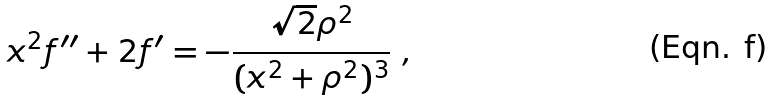<formula> <loc_0><loc_0><loc_500><loc_500>x ^ { 2 } f ^ { \prime \prime } + 2 f ^ { \prime } = - \frac { { \sqrt { 2 } } \rho ^ { 2 } } { ( x ^ { 2 } + \rho ^ { 2 } ) ^ { 3 } } \ ,</formula> 